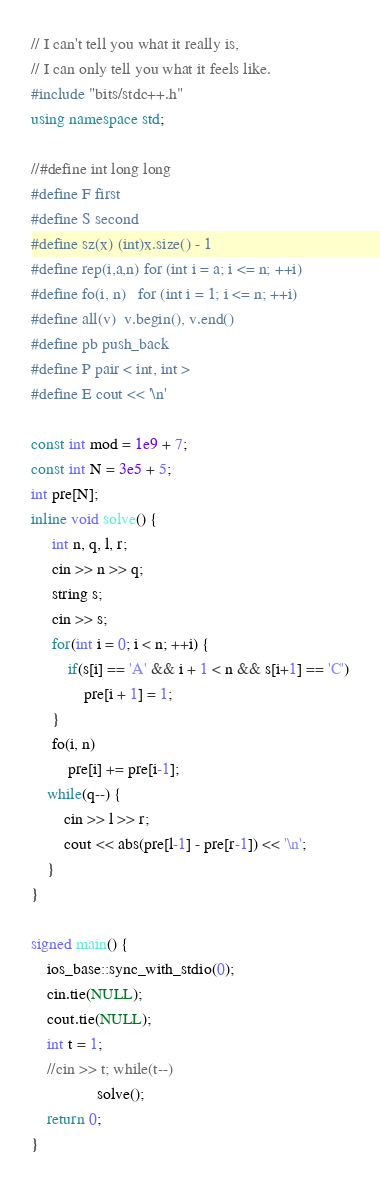<code> <loc_0><loc_0><loc_500><loc_500><_C++_>// I can't tell you what it really is,
// I can only tell you what it feels like.
#include "bits/stdc++.h"
using namespace std;

//#define int long long
#define F first
#define S second
#define sz(x) (int)x.size() - 1
#define rep(i,a,n) for (int i = a; i <= n; ++i)
#define fo(i, n)   for (int i = 1; i <= n; ++i)
#define all(v)  v.begin(), v.end()
#define pb push_back
#define P pair < int, int >
#define E cout << '\n'

const int mod = 1e9 + 7;
const int N = 3e5 + 5;
int pre[N];
inline void solve() {
     int n, q, l, r;
     cin >> n >> q;
     string s;
     cin >> s;
     for(int i = 0; i < n; ++i) {
         if(s[i] == 'A' && i + 1 < n && s[i+1] == 'C')
             pre[i + 1] = 1;
     }
     fo(i, n)
         pre[i] += pre[i-1];
    while(q--) {
        cin >> l >> r;
        cout << abs(pre[l-1] - pre[r-1]) << '\n';
    }
}

signed main() {
    ios_base::sync_with_stdio(0);
    cin.tie(NULL);
    cout.tie(NULL);
    int t = 1;
    //cin >> t; while(t--)
                solve();
    return 0;
}
</code> 